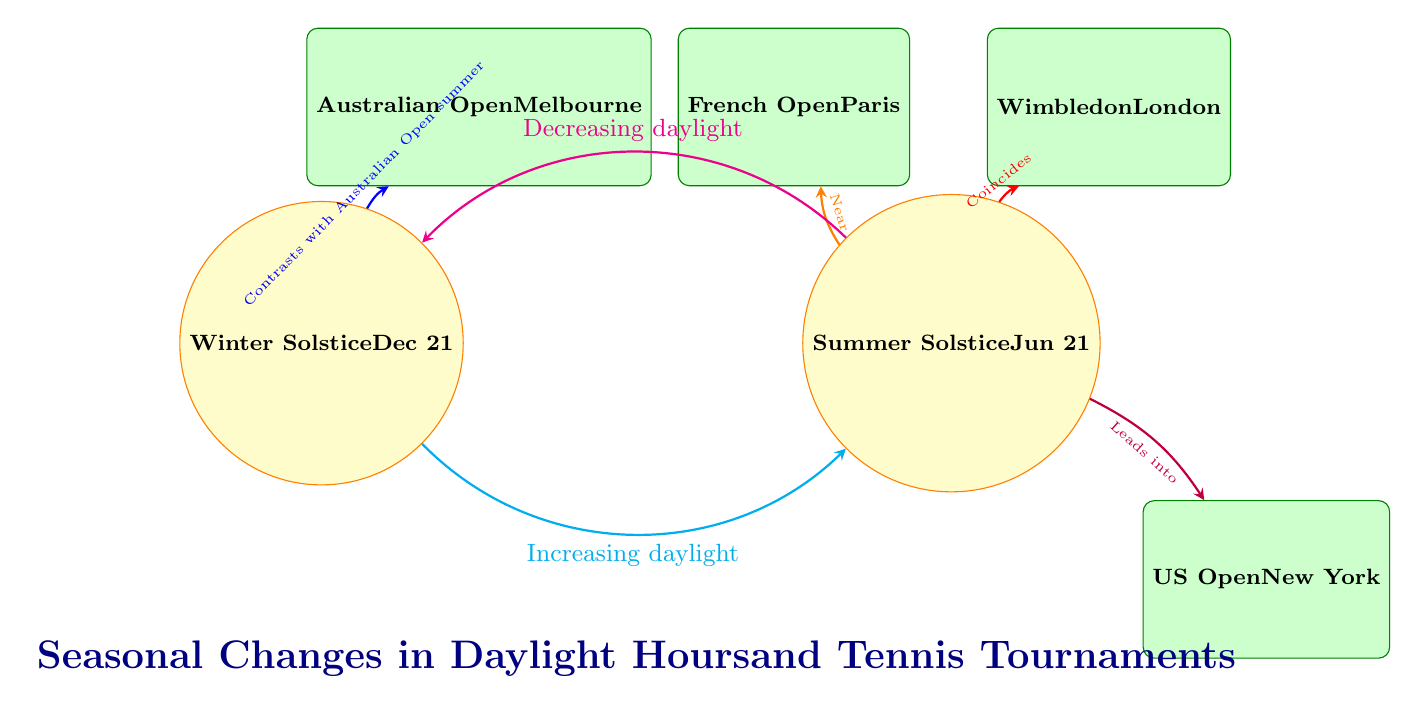What are the two solstices shown in the diagram? The diagram includes two solstices: Winter Solstice on December 21 and Summer Solstice on June 21. These are represented as nodes labeled with their corresponding dates and names.
Answer: Winter Solstice and Summer Solstice How many tennis tournaments are connected to the Summer Solstice? There are three tournaments connected to the Summer Solstice: the French Open, Wimbledon, and the US Open, which are all placed around the Summer Solstice node.
Answer: Three What type of relationship does the edge between Summer Solstice and Wimbledon represent? The edge labeled "Coincides" indicates that the Wimbledon tournament occurs at the same time as the Summer Solstice, showing a direct correlation in timing.
Answer: Coincides What does the edge labeled "Leads into" signify between Summer Solstice and the US Open? This edge signifies that as the days begin to shorten after the Summer Solstice, this leads into the time frame for the US Open, showing a progression from longer to shorter daylight hours.
Answer: Leads into What is the nature of the seasonal change depicted from Winter Solstice to Summer Solstice? The thick cyan arrow indicates an increasing trend in daylight hours as one moves from the Winter Solstice to the Summer Solstice, demonstrating the gradual change through the seasons.
Answer: Increasing daylight How does the edge connecting Winter Solstice with the Australian Open describe their relationship? The relationship is described by the edge labeled "Contrasts with Australian Open summer," indicating that the Winter Solstice represents a time of year with much shorter daylight hours compared to the Australian Open held in the summer.
Answer: Contrasts with Australian Open summer What seasonal trend is shown from Summer Solstice back to Winter Solstice in the diagram? The thick magenta arrow represents a decreasing trend in daylight hours when moving back from the Summer Solstice to the Winter Solstice, illustrating the seasonal change of shortening days.
Answer: Decreasing daylight Which two tournaments take place in proximity during the summer months? The two tournaments that take place in close succession during the summer are Wimbledon and the French Open, as they are both positioned near the Summer Solstice and are directly connected by edges showing their timing relationship.
Answer: Wimbledon and French Open 